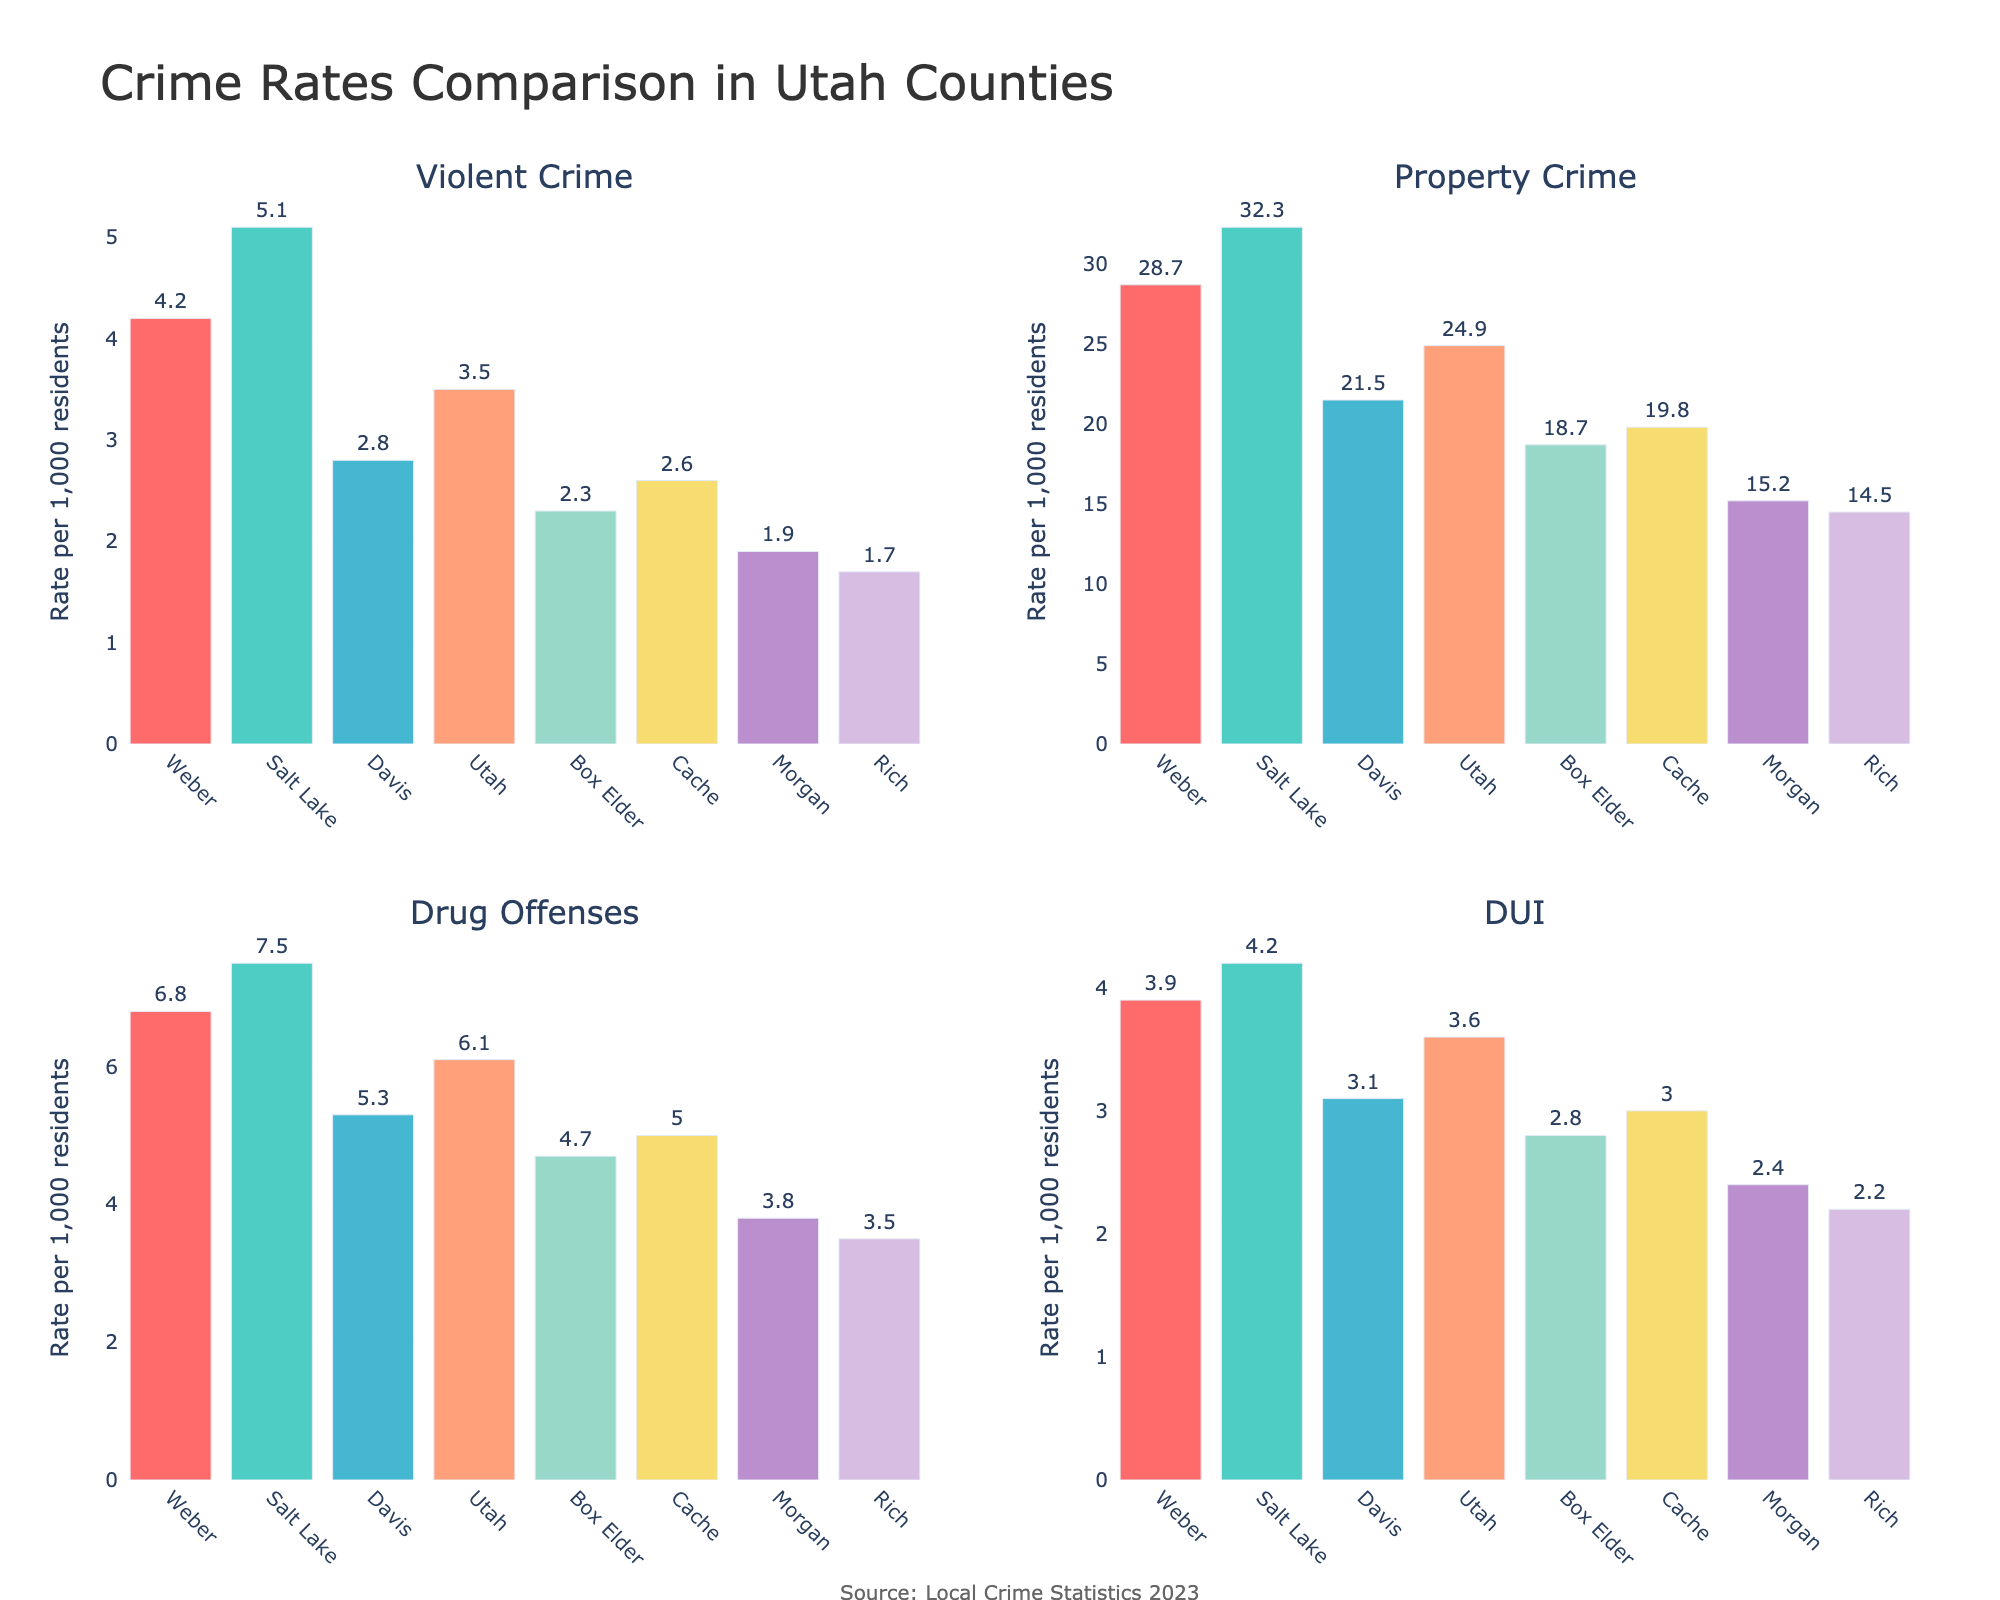What is the title of the figure? The title of a figure is usually located at the top center of the plot. In this case, it is displayed in a large font above the subplots.
Answer: Crime Rates Comparison in Utah Counties Which county has the highest property crime rate? The property crime rate for each county is shown on the subplot labeled "Property Crime". The bar for Salt Lake County is the tallest, indicating the highest rate.
Answer: Salt Lake What is the difference in violent crime rates between Weber and Morgan counties? First, identify the violent crime rates for Weber (4.2 per 1,000) and Morgan (1.9 per 1,000). Then, subtract the smaller rate from the larger one: 4.2 - 1.9 = 2.3.
Answer: 2.3 Which county has the lowest drug offense rate and what is that rate? By looking at the subplot labeled "Drug Offenses", the shortest bar corresponds to Rich County with a rate of 3.5 per 1,000 residents.
Answer: Rich, 3.5 How does the DUI rate in Box Elder County compare to Cache County? Both counties' DUI rates are shown in the "DUI" subplot. Box Elder has a rate of 2.8, while Cache has a rate of 3.0. Therefore, Box Elder's rate is lower than Cache's.
Answer: Box Elder's rate is lower What is the average drug offense rate across all counties? Sum the drug offense rates from all counties: 6.8 (Weber) + 7.5 (Salt Lake) + 5.3 (Davis) + 6.1 (Utah) + 4.7 (Box Elder) + 5.0 (Cache) + 3.8 (Morgan) + 3.5 (Rich) = 42.7. Then divide by the number of counties, 8. 42.7 / 8 = 5.34.
Answer: 5.34 Which two counties have the closest property crime rates? From visual inspection of the "Property Crime" subplot, Weber (28.7) and Utah (24.9) seem closest. However, by checking the values, Cache (19.8) and Box Elder (18.7) are actually the closest. The difference between Box Elder and Cache is 19.8 - 18.7 = 1.1, the smallest difference among any pairs.
Answer: Box Elder and Cache What is the difference between the DUI rates of the county with the highest rate and the county with the lowest rate? The highest DUI rate is in Salt Lake County (4.2) and the lowest is in Rich County (2.2). The difference is 4.2 - 2.2 = 2.0.
Answer: 2.0 How many counties have property crime rates greater than 20 per 1,000 residents? From the "Property Crime" subplot, count the number of bars exceeding the 20 mark: Weber, Salt Lake, Davis, and Utah. There are 4 such counties.
Answer: 4 